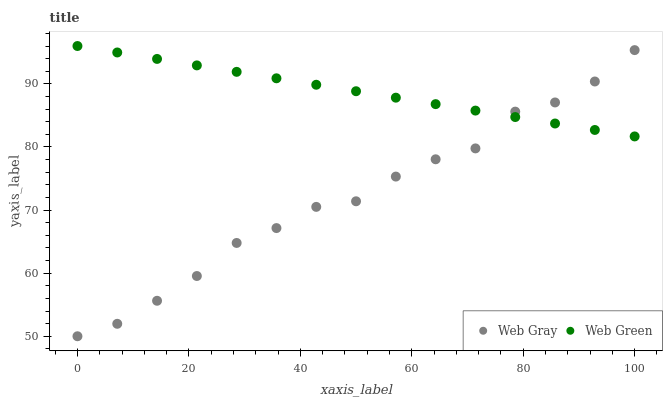Does Web Gray have the minimum area under the curve?
Answer yes or no. Yes. Does Web Green have the maximum area under the curve?
Answer yes or no. Yes. Does Web Green have the minimum area under the curve?
Answer yes or no. No. Is Web Green the smoothest?
Answer yes or no. Yes. Is Web Gray the roughest?
Answer yes or no. Yes. Is Web Green the roughest?
Answer yes or no. No. Does Web Gray have the lowest value?
Answer yes or no. Yes. Does Web Green have the lowest value?
Answer yes or no. No. Does Web Green have the highest value?
Answer yes or no. Yes. Does Web Green intersect Web Gray?
Answer yes or no. Yes. Is Web Green less than Web Gray?
Answer yes or no. No. Is Web Green greater than Web Gray?
Answer yes or no. No. 